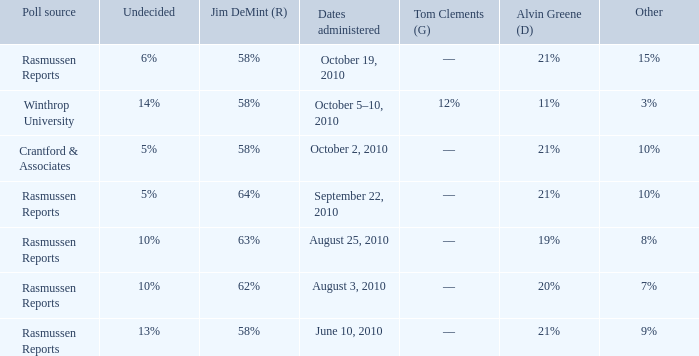Which poll source determined undecided of 5% and Jim DeMint (R) of 58%? Crantford & Associates. 